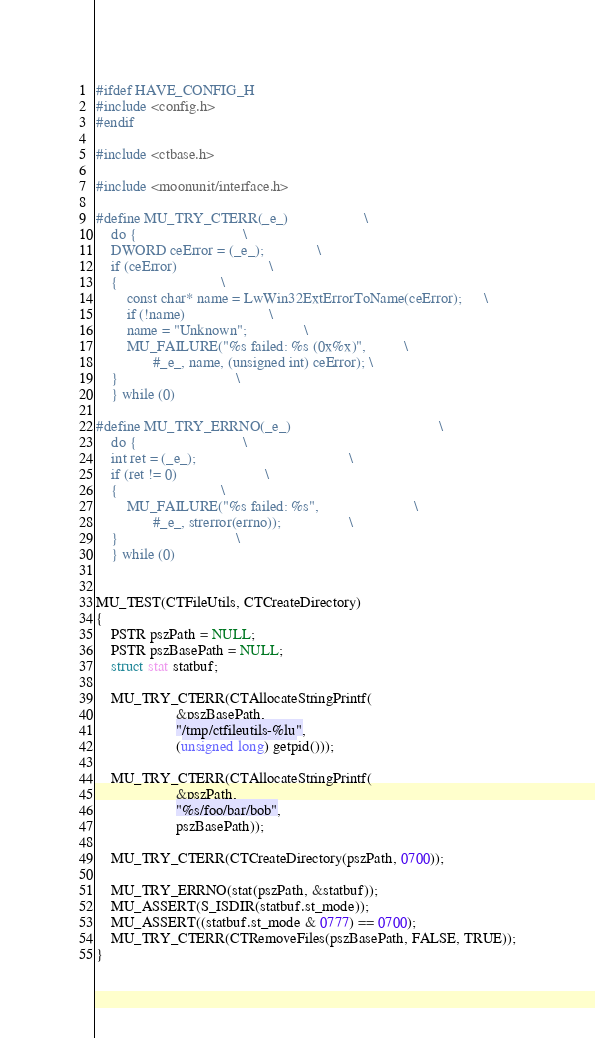<code> <loc_0><loc_0><loc_500><loc_500><_C_>#ifdef HAVE_CONFIG_H
#include <config.h>
#endif

#include <ctbase.h>

#include <moonunit/interface.h>

#define MU_TRY_CTERR(_e_)					\
    do {							\
	DWORD ceError = (_e_);				\
	if (ceError)						\
	{							\
	    const char* name = LwWin32ExtErrorToName(ceError);		\
	    if (!name)						\
		name = "Unknown";				\
	    MU_FAILURE("%s failed: %s (0x%x)",			\
		       #_e_, name, (unsigned int) ceError);	\
	}						        \
    } while (0)

#define MU_TRY_ERRNO(_e_)                                       \
    do {							\
	int ret = (_e_);                                        \
	if (ret != 0)						\
	{							\
	    MU_FAILURE("%s failed: %s",                         \
		       #_e_, strerror(errno));                  \
	}						        \
    } while (0)
        

MU_TEST(CTFileUtils, CTCreateDirectory)
{
    PSTR pszPath = NULL;
    PSTR pszBasePath = NULL;
    struct stat statbuf;

    MU_TRY_CTERR(CTAllocateStringPrintf(
                     &pszBasePath,
                     "/tmp/ctfileutils-%lu",
                     (unsigned long) getpid()));

    MU_TRY_CTERR(CTAllocateStringPrintf(
                     &pszPath,
                     "%s/foo/bar/bob",
                     pszBasePath));

    MU_TRY_CTERR(CTCreateDirectory(pszPath, 0700));

    MU_TRY_ERRNO(stat(pszPath, &statbuf));
    MU_ASSERT(S_ISDIR(statbuf.st_mode));
    MU_ASSERT((statbuf.st_mode & 0777) == 0700);
    MU_TRY_CTERR(CTRemoveFiles(pszBasePath, FALSE, TRUE));
}
</code> 